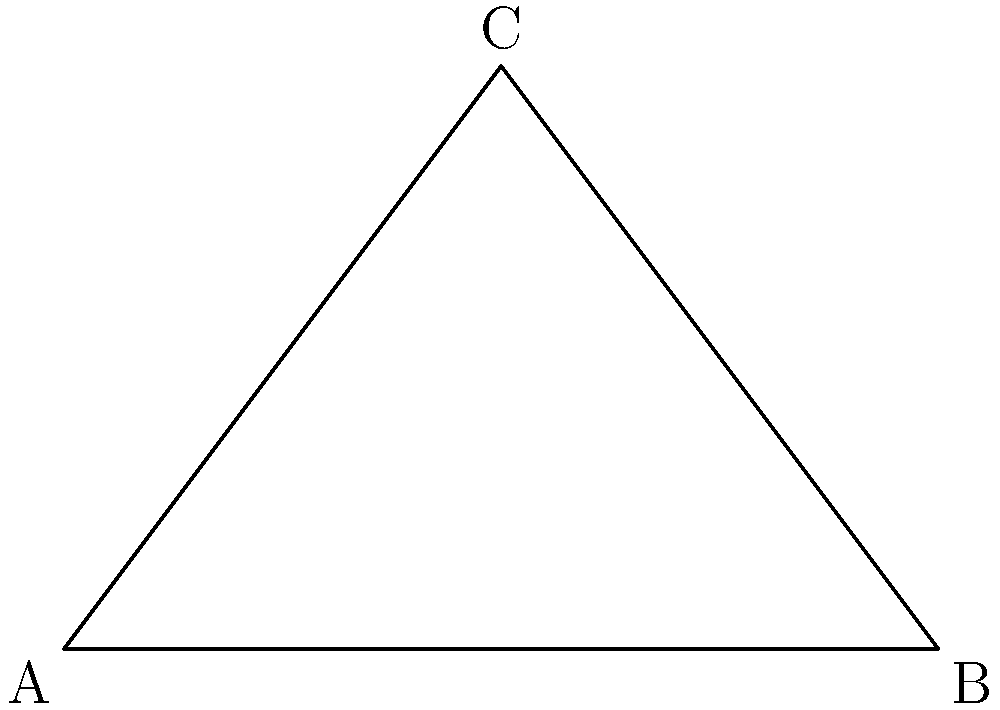In your newest escape room, you've strategically placed a crucial clue on the ceiling. The room is rectangular, measuring 6 meters in length. The clue is positioned 4 meters above the floor, directly over a point that's 3 meters from one end of the room. To ensure optimal visibility, you need to determine the viewing angle for participants standing at the far end of the room. What is the viewing angle in degrees? Let's approach this step-by-step:

1) The scenario forms a right-angled triangle. We can see this by imagining:
   - The floor of the room as the base (6 meters)
   - The wall as one side (4 meters)
   - The line of sight from the viewer to the clue as the hypotenuse

2) We're asked to find the angle at point A in this triangle.

3) We can use the tangent function to find this angle. The tangent of an angle in a right-angled triangle is the opposite side divided by the adjacent side.

4) In this case:
   - The opposite side is the height of the clue (4 meters)
   - The adjacent side is the full length of the room (6 meters)

5) So, we can set up the equation:
   
   $$\tan(\theta) = \frac{4}{6} = \frac{2}{3}$$

6) To find the angle, we need to use the inverse tangent (arctan or $\tan^{-1}$):

   $$\theta = \tan^{-1}(\frac{2}{3})$$

7) Using a calculator or computer, we can compute this:

   $$\theta \approx 33.69°$$

8) Rounding to the nearest degree gives us 34°.

This angle ensures that participants at the far end of the room will have the optimal viewing angle for the ceiling clue, balancing visibility with the challenge of discovery.
Answer: 34° 